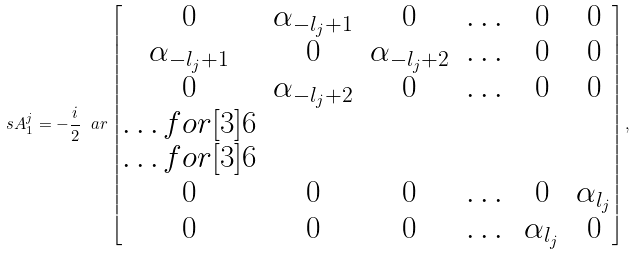<formula> <loc_0><loc_0><loc_500><loc_500>\ s A ^ { j } _ { 1 } = - \frac { i } { 2 } \ a r \begin{bmatrix} 0 & \alpha _ { - l _ { j } + 1 } & 0 & \dots & 0 & 0 \\ \alpha _ { - l _ { j } + 1 } & 0 & \alpha _ { - l _ { j } + 2 } & \dots & 0 & 0 \\ 0 & \alpha _ { - l _ { j } + 2 } & 0 & \dots & 0 & 0 \\ \hdots f o r [ 3 ] { 6 } \\ \hdots f o r [ 3 ] { 6 } \\ 0 & 0 & 0 & \dots & 0 & \alpha _ { l _ { j } } \\ 0 & 0 & 0 & \dots & \alpha _ { l _ { j } } & 0 \end{bmatrix} ,</formula> 